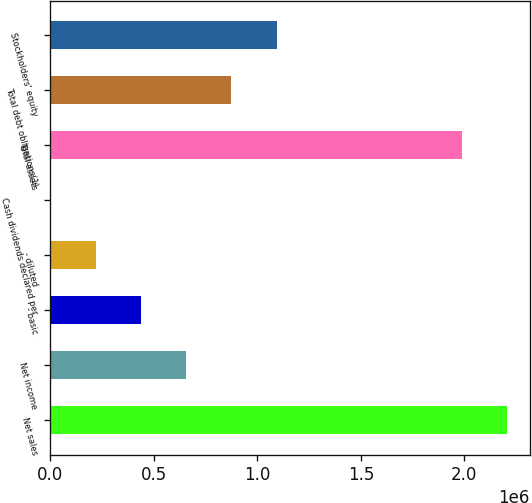Convert chart. <chart><loc_0><loc_0><loc_500><loc_500><bar_chart><fcel>Net sales<fcel>Net income<fcel>- basic<fcel>- diluted<fcel>Cash dividends declared per<fcel>Total assets<fcel>Total debt obligations(1)<fcel>Stockholders' equity<nl><fcel>2.20568e+06<fcel>656114<fcel>437410<fcel>218706<fcel>1<fcel>1.98698e+06<fcel>874819<fcel>1.09352e+06<nl></chart> 